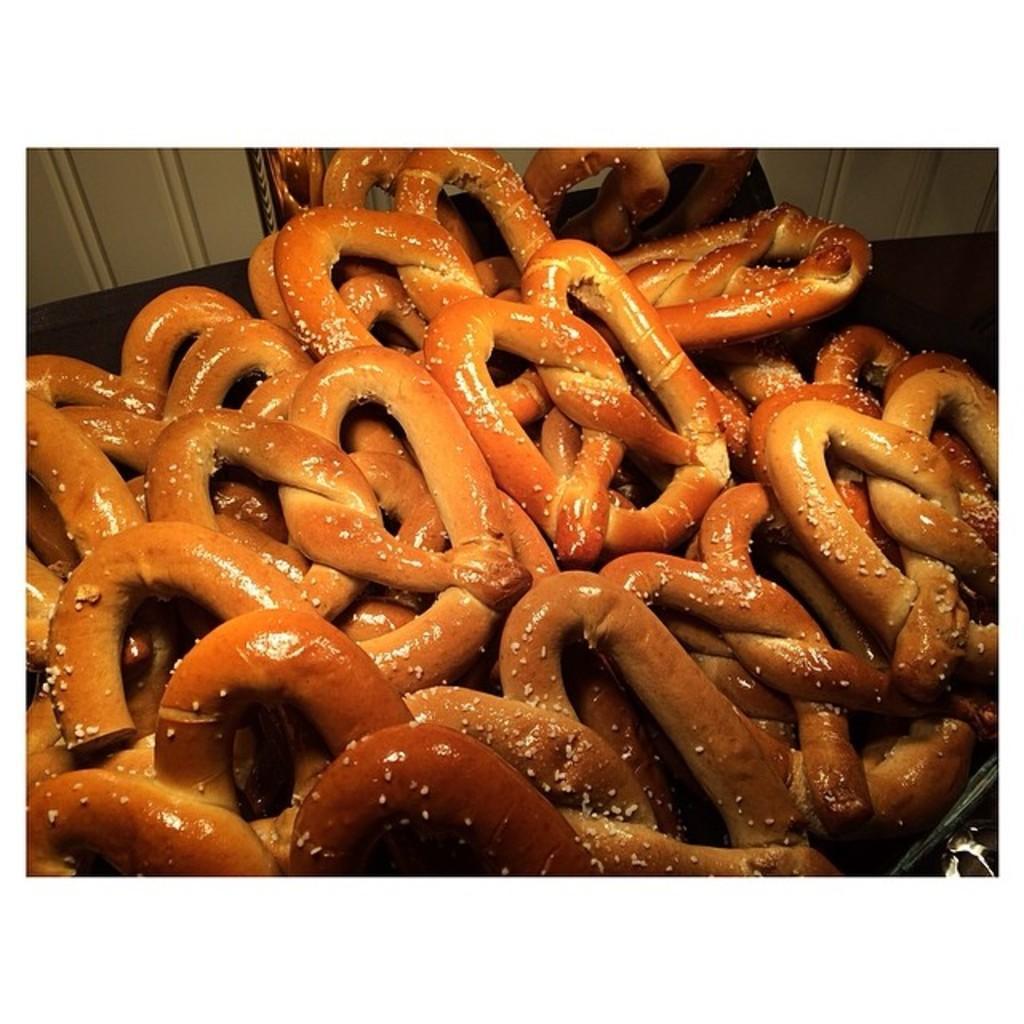In one or two sentences, can you explain what this image depicts? In this picture we can see some food items on an object. Behind the food there is a wall. 